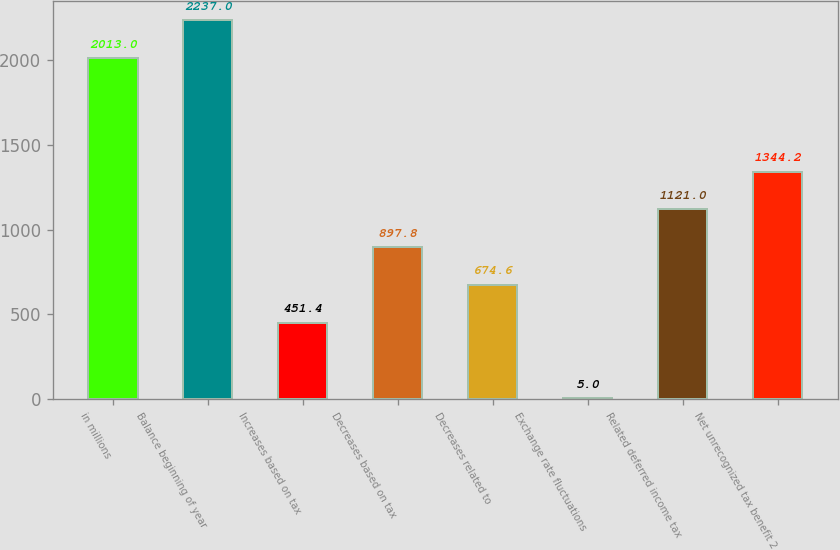Convert chart. <chart><loc_0><loc_0><loc_500><loc_500><bar_chart><fcel>in millions<fcel>Balance beginning of year<fcel>Increases based on tax<fcel>Decreases based on tax<fcel>Decreases related to<fcel>Exchange rate fluctuations<fcel>Related deferred income tax<fcel>Net unrecognized tax benefit 2<nl><fcel>2013<fcel>2237<fcel>451.4<fcel>897.8<fcel>674.6<fcel>5<fcel>1121<fcel>1344.2<nl></chart> 